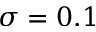Convert formula to latex. <formula><loc_0><loc_0><loc_500><loc_500>\sigma = 0 . 1</formula> 